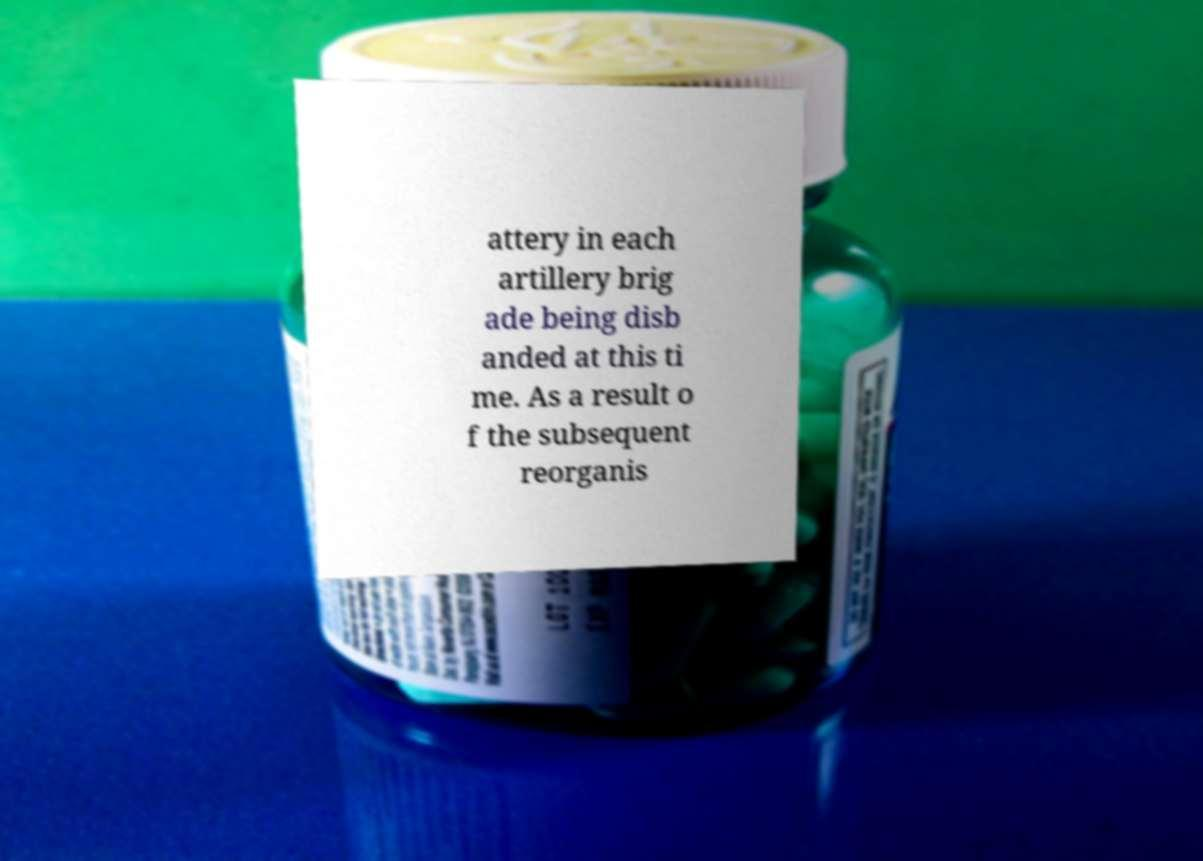What messages or text are displayed in this image? I need them in a readable, typed format. attery in each artillery brig ade being disb anded at this ti me. As a result o f the subsequent reorganis 